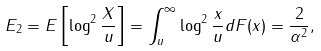<formula> <loc_0><loc_0><loc_500><loc_500>E _ { 2 } = E \left [ \log ^ { 2 } \frac { X } { u } \right ] = \int _ { u } ^ { \infty } \log ^ { 2 } \frac { x } { u } d F ( x ) = \frac { 2 } { \alpha ^ { 2 } } ,</formula> 